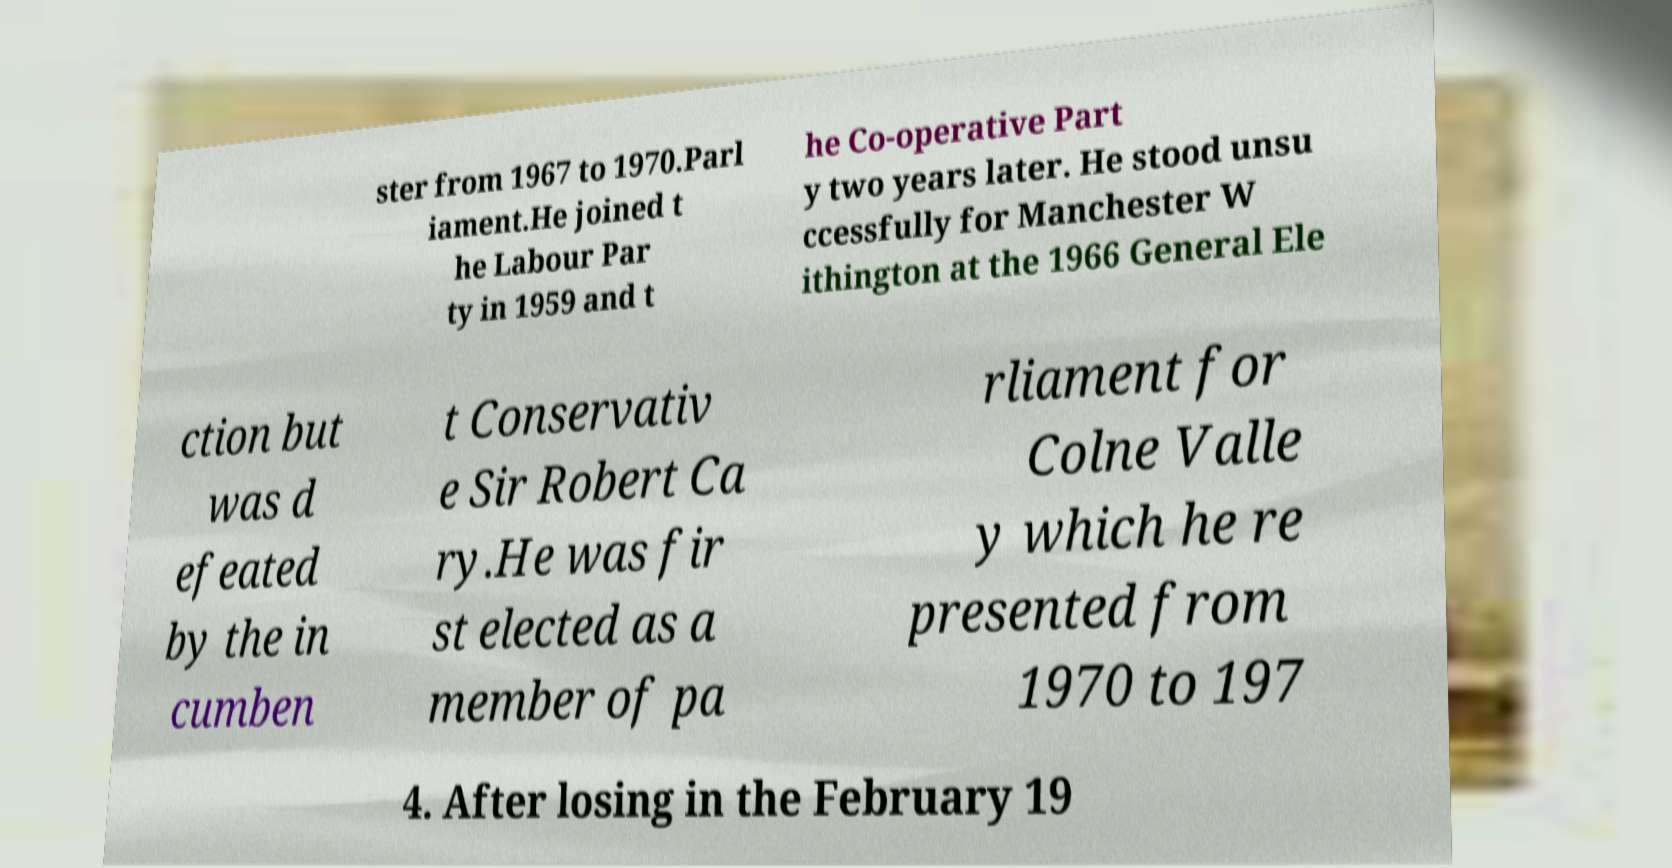Please read and relay the text visible in this image. What does it say? ster from 1967 to 1970.Parl iament.He joined t he Labour Par ty in 1959 and t he Co-operative Part y two years later. He stood unsu ccessfully for Manchester W ithington at the 1966 General Ele ction but was d efeated by the in cumben t Conservativ e Sir Robert Ca ry.He was fir st elected as a member of pa rliament for Colne Valle y which he re presented from 1970 to 197 4. After losing in the February 19 